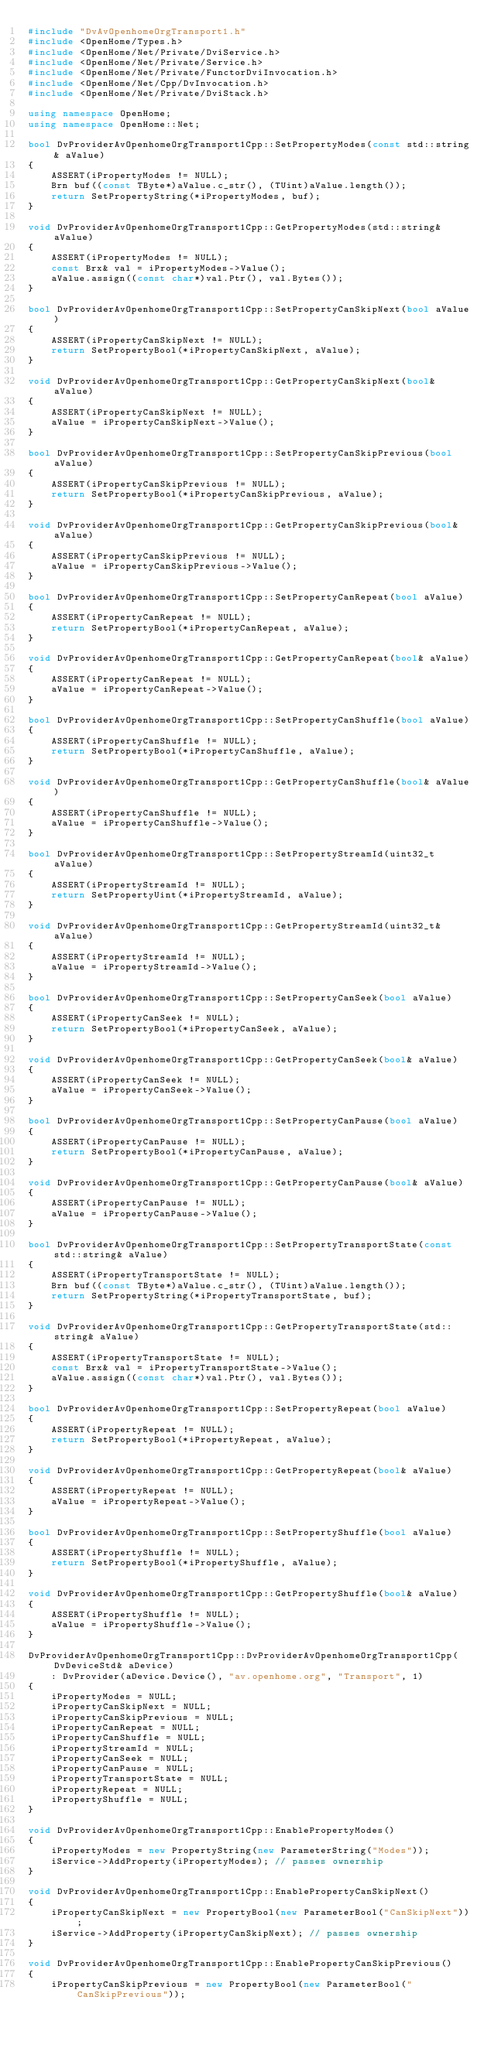Convert code to text. <code><loc_0><loc_0><loc_500><loc_500><_C++_>#include "DvAvOpenhomeOrgTransport1.h"
#include <OpenHome/Types.h>
#include <OpenHome/Net/Private/DviService.h>
#include <OpenHome/Net/Private/Service.h>
#include <OpenHome/Net/Private/FunctorDviInvocation.h>
#include <OpenHome/Net/Cpp/DvInvocation.h>
#include <OpenHome/Net/Private/DviStack.h>

using namespace OpenHome;
using namespace OpenHome::Net;

bool DvProviderAvOpenhomeOrgTransport1Cpp::SetPropertyModes(const std::string& aValue)
{
    ASSERT(iPropertyModes != NULL);
    Brn buf((const TByte*)aValue.c_str(), (TUint)aValue.length());
    return SetPropertyString(*iPropertyModes, buf);
}

void DvProviderAvOpenhomeOrgTransport1Cpp::GetPropertyModes(std::string& aValue)
{
    ASSERT(iPropertyModes != NULL);
    const Brx& val = iPropertyModes->Value();
    aValue.assign((const char*)val.Ptr(), val.Bytes());
}

bool DvProviderAvOpenhomeOrgTransport1Cpp::SetPropertyCanSkipNext(bool aValue)
{
    ASSERT(iPropertyCanSkipNext != NULL);
    return SetPropertyBool(*iPropertyCanSkipNext, aValue);
}

void DvProviderAvOpenhomeOrgTransport1Cpp::GetPropertyCanSkipNext(bool& aValue)
{
    ASSERT(iPropertyCanSkipNext != NULL);
    aValue = iPropertyCanSkipNext->Value();
}

bool DvProviderAvOpenhomeOrgTransport1Cpp::SetPropertyCanSkipPrevious(bool aValue)
{
    ASSERT(iPropertyCanSkipPrevious != NULL);
    return SetPropertyBool(*iPropertyCanSkipPrevious, aValue);
}

void DvProviderAvOpenhomeOrgTransport1Cpp::GetPropertyCanSkipPrevious(bool& aValue)
{
    ASSERT(iPropertyCanSkipPrevious != NULL);
    aValue = iPropertyCanSkipPrevious->Value();
}

bool DvProviderAvOpenhomeOrgTransport1Cpp::SetPropertyCanRepeat(bool aValue)
{
    ASSERT(iPropertyCanRepeat != NULL);
    return SetPropertyBool(*iPropertyCanRepeat, aValue);
}

void DvProviderAvOpenhomeOrgTransport1Cpp::GetPropertyCanRepeat(bool& aValue)
{
    ASSERT(iPropertyCanRepeat != NULL);
    aValue = iPropertyCanRepeat->Value();
}

bool DvProviderAvOpenhomeOrgTransport1Cpp::SetPropertyCanShuffle(bool aValue)
{
    ASSERT(iPropertyCanShuffle != NULL);
    return SetPropertyBool(*iPropertyCanShuffle, aValue);
}

void DvProviderAvOpenhomeOrgTransport1Cpp::GetPropertyCanShuffle(bool& aValue)
{
    ASSERT(iPropertyCanShuffle != NULL);
    aValue = iPropertyCanShuffle->Value();
}

bool DvProviderAvOpenhomeOrgTransport1Cpp::SetPropertyStreamId(uint32_t aValue)
{
    ASSERT(iPropertyStreamId != NULL);
    return SetPropertyUint(*iPropertyStreamId, aValue);
}

void DvProviderAvOpenhomeOrgTransport1Cpp::GetPropertyStreamId(uint32_t& aValue)
{
    ASSERT(iPropertyStreamId != NULL);
    aValue = iPropertyStreamId->Value();
}

bool DvProviderAvOpenhomeOrgTransport1Cpp::SetPropertyCanSeek(bool aValue)
{
    ASSERT(iPropertyCanSeek != NULL);
    return SetPropertyBool(*iPropertyCanSeek, aValue);
}

void DvProviderAvOpenhomeOrgTransport1Cpp::GetPropertyCanSeek(bool& aValue)
{
    ASSERT(iPropertyCanSeek != NULL);
    aValue = iPropertyCanSeek->Value();
}

bool DvProviderAvOpenhomeOrgTransport1Cpp::SetPropertyCanPause(bool aValue)
{
    ASSERT(iPropertyCanPause != NULL);
    return SetPropertyBool(*iPropertyCanPause, aValue);
}

void DvProviderAvOpenhomeOrgTransport1Cpp::GetPropertyCanPause(bool& aValue)
{
    ASSERT(iPropertyCanPause != NULL);
    aValue = iPropertyCanPause->Value();
}

bool DvProviderAvOpenhomeOrgTransport1Cpp::SetPropertyTransportState(const std::string& aValue)
{
    ASSERT(iPropertyTransportState != NULL);
    Brn buf((const TByte*)aValue.c_str(), (TUint)aValue.length());
    return SetPropertyString(*iPropertyTransportState, buf);
}

void DvProviderAvOpenhomeOrgTransport1Cpp::GetPropertyTransportState(std::string& aValue)
{
    ASSERT(iPropertyTransportState != NULL);
    const Brx& val = iPropertyTransportState->Value();
    aValue.assign((const char*)val.Ptr(), val.Bytes());
}

bool DvProviderAvOpenhomeOrgTransport1Cpp::SetPropertyRepeat(bool aValue)
{
    ASSERT(iPropertyRepeat != NULL);
    return SetPropertyBool(*iPropertyRepeat, aValue);
}

void DvProviderAvOpenhomeOrgTransport1Cpp::GetPropertyRepeat(bool& aValue)
{
    ASSERT(iPropertyRepeat != NULL);
    aValue = iPropertyRepeat->Value();
}

bool DvProviderAvOpenhomeOrgTransport1Cpp::SetPropertyShuffle(bool aValue)
{
    ASSERT(iPropertyShuffle != NULL);
    return SetPropertyBool(*iPropertyShuffle, aValue);
}

void DvProviderAvOpenhomeOrgTransport1Cpp::GetPropertyShuffle(bool& aValue)
{
    ASSERT(iPropertyShuffle != NULL);
    aValue = iPropertyShuffle->Value();
}

DvProviderAvOpenhomeOrgTransport1Cpp::DvProviderAvOpenhomeOrgTransport1Cpp(DvDeviceStd& aDevice)
    : DvProvider(aDevice.Device(), "av.openhome.org", "Transport", 1)
{
    iPropertyModes = NULL;
    iPropertyCanSkipNext = NULL;
    iPropertyCanSkipPrevious = NULL;
    iPropertyCanRepeat = NULL;
    iPropertyCanShuffle = NULL;
    iPropertyStreamId = NULL;
    iPropertyCanSeek = NULL;
    iPropertyCanPause = NULL;
    iPropertyTransportState = NULL;
    iPropertyRepeat = NULL;
    iPropertyShuffle = NULL;
}

void DvProviderAvOpenhomeOrgTransport1Cpp::EnablePropertyModes()
{
    iPropertyModes = new PropertyString(new ParameterString("Modes"));
    iService->AddProperty(iPropertyModes); // passes ownership
}

void DvProviderAvOpenhomeOrgTransport1Cpp::EnablePropertyCanSkipNext()
{
    iPropertyCanSkipNext = new PropertyBool(new ParameterBool("CanSkipNext"));
    iService->AddProperty(iPropertyCanSkipNext); // passes ownership
}

void DvProviderAvOpenhomeOrgTransport1Cpp::EnablePropertyCanSkipPrevious()
{
    iPropertyCanSkipPrevious = new PropertyBool(new ParameterBool("CanSkipPrevious"));</code> 